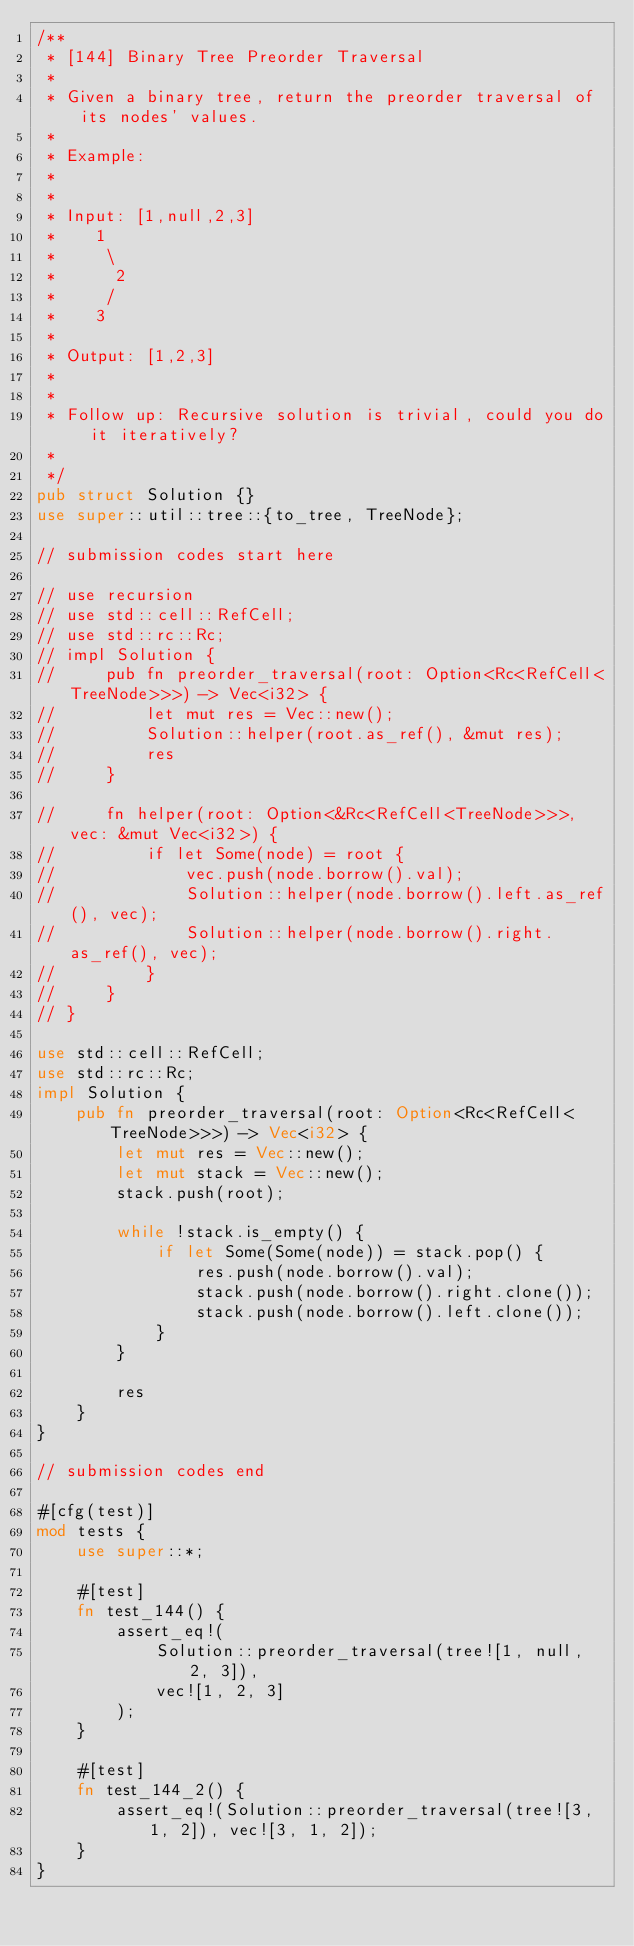<code> <loc_0><loc_0><loc_500><loc_500><_Rust_>/**
 * [144] Binary Tree Preorder Traversal
 *
 * Given a binary tree, return the preorder traversal of its nodes' values.
 *
 * Example:
 *
 *
 * Input: [1,null,2,3]
 *    1
 *     \
 *      2
 *     /
 *    3
 *
 * Output: [1,2,3]
 *
 *
 * Follow up: Recursive solution is trivial, could you do it iteratively?
 *
 */
pub struct Solution {}
use super::util::tree::{to_tree, TreeNode};

// submission codes start here

// use recursion
// use std::cell::RefCell;
// use std::rc::Rc;
// impl Solution {
//     pub fn preorder_traversal(root: Option<Rc<RefCell<TreeNode>>>) -> Vec<i32> {
//         let mut res = Vec::new();
//         Solution::helper(root.as_ref(), &mut res);
//         res
//     }

//     fn helper(root: Option<&Rc<RefCell<TreeNode>>>, vec: &mut Vec<i32>) {
//         if let Some(node) = root {
//             vec.push(node.borrow().val);
//             Solution::helper(node.borrow().left.as_ref(), vec);
//             Solution::helper(node.borrow().right.as_ref(), vec);
//         }
//     }
// }

use std::cell::RefCell;
use std::rc::Rc;
impl Solution {
    pub fn preorder_traversal(root: Option<Rc<RefCell<TreeNode>>>) -> Vec<i32> {
        let mut res = Vec::new();
        let mut stack = Vec::new();
        stack.push(root);

        while !stack.is_empty() {
            if let Some(Some(node)) = stack.pop() {
                res.push(node.borrow().val);
                stack.push(node.borrow().right.clone());
                stack.push(node.borrow().left.clone());
            }
        }

        res
    }
}

// submission codes end

#[cfg(test)]
mod tests {
    use super::*;

    #[test]
    fn test_144() {
        assert_eq!(
            Solution::preorder_traversal(tree![1, null, 2, 3]),
            vec![1, 2, 3]
        );
    }

    #[test]
    fn test_144_2() {
        assert_eq!(Solution::preorder_traversal(tree![3, 1, 2]), vec![3, 1, 2]);
    }
}
</code> 